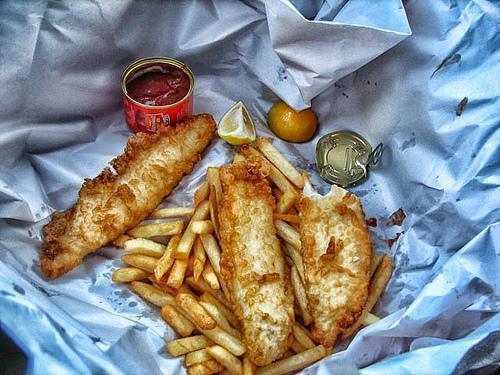How many pieces of fish?
Give a very brief answer. 3. 